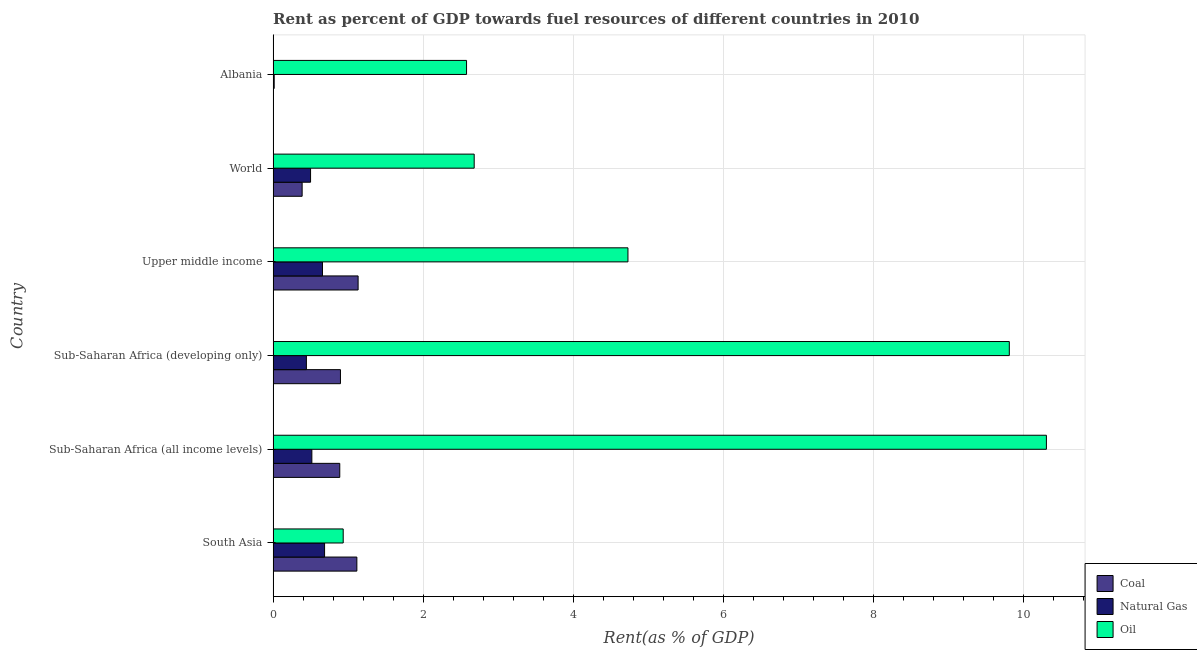How many groups of bars are there?
Your answer should be very brief. 6. Are the number of bars per tick equal to the number of legend labels?
Offer a very short reply. Yes. How many bars are there on the 4th tick from the top?
Keep it short and to the point. 3. What is the label of the 5th group of bars from the top?
Give a very brief answer. Sub-Saharan Africa (all income levels). In how many cases, is the number of bars for a given country not equal to the number of legend labels?
Give a very brief answer. 0. What is the rent towards natural gas in Albania?
Make the answer very short. 0.01. Across all countries, what is the maximum rent towards oil?
Offer a terse response. 10.31. Across all countries, what is the minimum rent towards oil?
Make the answer very short. 0.93. In which country was the rent towards natural gas maximum?
Offer a very short reply. South Asia. In which country was the rent towards coal minimum?
Provide a succinct answer. Albania. What is the total rent towards oil in the graph?
Your answer should be very brief. 31.05. What is the difference between the rent towards coal in Sub-Saharan Africa (all income levels) and that in Upper middle income?
Your response must be concise. -0.24. What is the difference between the rent towards coal in World and the rent towards natural gas in Albania?
Keep it short and to the point. 0.37. What is the average rent towards coal per country?
Your answer should be very brief. 0.74. What is the difference between the rent towards oil and rent towards natural gas in Sub-Saharan Africa (developing only)?
Give a very brief answer. 9.37. In how many countries, is the rent towards coal greater than 3.2 %?
Ensure brevity in your answer.  0. What is the ratio of the rent towards oil in Sub-Saharan Africa (developing only) to that in Upper middle income?
Provide a short and direct response. 2.08. Is the rent towards natural gas in South Asia less than that in Upper middle income?
Give a very brief answer. No. What is the difference between the highest and the second highest rent towards natural gas?
Provide a succinct answer. 0.03. What is the difference between the highest and the lowest rent towards oil?
Give a very brief answer. 9.38. Is the sum of the rent towards oil in Sub-Saharan Africa (developing only) and Upper middle income greater than the maximum rent towards natural gas across all countries?
Keep it short and to the point. Yes. What does the 2nd bar from the top in Upper middle income represents?
Provide a short and direct response. Natural Gas. What does the 1st bar from the bottom in Albania represents?
Provide a succinct answer. Coal. Is it the case that in every country, the sum of the rent towards coal and rent towards natural gas is greater than the rent towards oil?
Your response must be concise. No. How many countries are there in the graph?
Make the answer very short. 6. Are the values on the major ticks of X-axis written in scientific E-notation?
Offer a terse response. No. Where does the legend appear in the graph?
Make the answer very short. Bottom right. How many legend labels are there?
Provide a succinct answer. 3. What is the title of the graph?
Your answer should be compact. Rent as percent of GDP towards fuel resources of different countries in 2010. What is the label or title of the X-axis?
Your answer should be very brief. Rent(as % of GDP). What is the Rent(as % of GDP) of Coal in South Asia?
Offer a very short reply. 1.12. What is the Rent(as % of GDP) in Natural Gas in South Asia?
Make the answer very short. 0.69. What is the Rent(as % of GDP) of Oil in South Asia?
Provide a short and direct response. 0.93. What is the Rent(as % of GDP) in Coal in Sub-Saharan Africa (all income levels)?
Make the answer very short. 0.89. What is the Rent(as % of GDP) in Natural Gas in Sub-Saharan Africa (all income levels)?
Your response must be concise. 0.52. What is the Rent(as % of GDP) in Oil in Sub-Saharan Africa (all income levels)?
Your answer should be compact. 10.31. What is the Rent(as % of GDP) of Coal in Sub-Saharan Africa (developing only)?
Your answer should be compact. 0.9. What is the Rent(as % of GDP) in Natural Gas in Sub-Saharan Africa (developing only)?
Your response must be concise. 0.44. What is the Rent(as % of GDP) in Oil in Sub-Saharan Africa (developing only)?
Keep it short and to the point. 9.82. What is the Rent(as % of GDP) of Coal in Upper middle income?
Keep it short and to the point. 1.13. What is the Rent(as % of GDP) of Natural Gas in Upper middle income?
Keep it short and to the point. 0.66. What is the Rent(as % of GDP) of Oil in Upper middle income?
Make the answer very short. 4.73. What is the Rent(as % of GDP) in Coal in World?
Your response must be concise. 0.39. What is the Rent(as % of GDP) of Natural Gas in World?
Keep it short and to the point. 0.5. What is the Rent(as % of GDP) of Oil in World?
Provide a succinct answer. 2.68. What is the Rent(as % of GDP) in Coal in Albania?
Make the answer very short. 0. What is the Rent(as % of GDP) of Natural Gas in Albania?
Your response must be concise. 0.01. What is the Rent(as % of GDP) in Oil in Albania?
Provide a succinct answer. 2.58. Across all countries, what is the maximum Rent(as % of GDP) in Coal?
Provide a short and direct response. 1.13. Across all countries, what is the maximum Rent(as % of GDP) in Natural Gas?
Give a very brief answer. 0.69. Across all countries, what is the maximum Rent(as % of GDP) of Oil?
Your answer should be compact. 10.31. Across all countries, what is the minimum Rent(as % of GDP) in Coal?
Offer a very short reply. 0. Across all countries, what is the minimum Rent(as % of GDP) in Natural Gas?
Ensure brevity in your answer.  0.01. Across all countries, what is the minimum Rent(as % of GDP) in Oil?
Keep it short and to the point. 0.93. What is the total Rent(as % of GDP) in Coal in the graph?
Keep it short and to the point. 4.42. What is the total Rent(as % of GDP) of Natural Gas in the graph?
Offer a very short reply. 2.82. What is the total Rent(as % of GDP) of Oil in the graph?
Keep it short and to the point. 31.05. What is the difference between the Rent(as % of GDP) of Coal in South Asia and that in Sub-Saharan Africa (all income levels)?
Ensure brevity in your answer.  0.23. What is the difference between the Rent(as % of GDP) in Natural Gas in South Asia and that in Sub-Saharan Africa (all income levels)?
Your answer should be very brief. 0.17. What is the difference between the Rent(as % of GDP) of Oil in South Asia and that in Sub-Saharan Africa (all income levels)?
Your response must be concise. -9.38. What is the difference between the Rent(as % of GDP) in Coal in South Asia and that in Sub-Saharan Africa (developing only)?
Your answer should be very brief. 0.22. What is the difference between the Rent(as % of GDP) in Natural Gas in South Asia and that in Sub-Saharan Africa (developing only)?
Make the answer very short. 0.24. What is the difference between the Rent(as % of GDP) of Oil in South Asia and that in Sub-Saharan Africa (developing only)?
Provide a succinct answer. -8.88. What is the difference between the Rent(as % of GDP) in Coal in South Asia and that in Upper middle income?
Provide a short and direct response. -0.02. What is the difference between the Rent(as % of GDP) in Natural Gas in South Asia and that in Upper middle income?
Your response must be concise. 0.03. What is the difference between the Rent(as % of GDP) in Oil in South Asia and that in Upper middle income?
Provide a short and direct response. -3.8. What is the difference between the Rent(as % of GDP) of Coal in South Asia and that in World?
Your answer should be very brief. 0.73. What is the difference between the Rent(as % of GDP) in Natural Gas in South Asia and that in World?
Offer a terse response. 0.19. What is the difference between the Rent(as % of GDP) of Oil in South Asia and that in World?
Your answer should be very brief. -1.75. What is the difference between the Rent(as % of GDP) in Coal in South Asia and that in Albania?
Provide a succinct answer. 1.12. What is the difference between the Rent(as % of GDP) in Natural Gas in South Asia and that in Albania?
Offer a terse response. 0.67. What is the difference between the Rent(as % of GDP) of Oil in South Asia and that in Albania?
Provide a short and direct response. -1.64. What is the difference between the Rent(as % of GDP) of Coal in Sub-Saharan Africa (all income levels) and that in Sub-Saharan Africa (developing only)?
Keep it short and to the point. -0.01. What is the difference between the Rent(as % of GDP) of Natural Gas in Sub-Saharan Africa (all income levels) and that in Sub-Saharan Africa (developing only)?
Your response must be concise. 0.07. What is the difference between the Rent(as % of GDP) in Oil in Sub-Saharan Africa (all income levels) and that in Sub-Saharan Africa (developing only)?
Your response must be concise. 0.49. What is the difference between the Rent(as % of GDP) in Coal in Sub-Saharan Africa (all income levels) and that in Upper middle income?
Provide a succinct answer. -0.24. What is the difference between the Rent(as % of GDP) in Natural Gas in Sub-Saharan Africa (all income levels) and that in Upper middle income?
Ensure brevity in your answer.  -0.14. What is the difference between the Rent(as % of GDP) in Oil in Sub-Saharan Africa (all income levels) and that in Upper middle income?
Offer a terse response. 5.58. What is the difference between the Rent(as % of GDP) of Coal in Sub-Saharan Africa (all income levels) and that in World?
Your response must be concise. 0.5. What is the difference between the Rent(as % of GDP) in Natural Gas in Sub-Saharan Africa (all income levels) and that in World?
Make the answer very short. 0.02. What is the difference between the Rent(as % of GDP) of Oil in Sub-Saharan Africa (all income levels) and that in World?
Give a very brief answer. 7.63. What is the difference between the Rent(as % of GDP) in Coal in Sub-Saharan Africa (all income levels) and that in Albania?
Make the answer very short. 0.89. What is the difference between the Rent(as % of GDP) in Natural Gas in Sub-Saharan Africa (all income levels) and that in Albania?
Keep it short and to the point. 0.5. What is the difference between the Rent(as % of GDP) of Oil in Sub-Saharan Africa (all income levels) and that in Albania?
Your answer should be very brief. 7.73. What is the difference between the Rent(as % of GDP) of Coal in Sub-Saharan Africa (developing only) and that in Upper middle income?
Offer a very short reply. -0.24. What is the difference between the Rent(as % of GDP) in Natural Gas in Sub-Saharan Africa (developing only) and that in Upper middle income?
Ensure brevity in your answer.  -0.21. What is the difference between the Rent(as % of GDP) of Oil in Sub-Saharan Africa (developing only) and that in Upper middle income?
Keep it short and to the point. 5.08. What is the difference between the Rent(as % of GDP) of Coal in Sub-Saharan Africa (developing only) and that in World?
Your response must be concise. 0.51. What is the difference between the Rent(as % of GDP) of Natural Gas in Sub-Saharan Africa (developing only) and that in World?
Provide a succinct answer. -0.06. What is the difference between the Rent(as % of GDP) of Oil in Sub-Saharan Africa (developing only) and that in World?
Ensure brevity in your answer.  7.13. What is the difference between the Rent(as % of GDP) in Coal in Sub-Saharan Africa (developing only) and that in Albania?
Your answer should be compact. 0.9. What is the difference between the Rent(as % of GDP) in Natural Gas in Sub-Saharan Africa (developing only) and that in Albania?
Keep it short and to the point. 0.43. What is the difference between the Rent(as % of GDP) of Oil in Sub-Saharan Africa (developing only) and that in Albania?
Offer a terse response. 7.24. What is the difference between the Rent(as % of GDP) in Coal in Upper middle income and that in World?
Offer a terse response. 0.75. What is the difference between the Rent(as % of GDP) of Natural Gas in Upper middle income and that in World?
Keep it short and to the point. 0.16. What is the difference between the Rent(as % of GDP) of Oil in Upper middle income and that in World?
Offer a terse response. 2.05. What is the difference between the Rent(as % of GDP) of Coal in Upper middle income and that in Albania?
Give a very brief answer. 1.13. What is the difference between the Rent(as % of GDP) in Natural Gas in Upper middle income and that in Albania?
Make the answer very short. 0.64. What is the difference between the Rent(as % of GDP) in Oil in Upper middle income and that in Albania?
Your answer should be very brief. 2.15. What is the difference between the Rent(as % of GDP) in Coal in World and that in Albania?
Offer a terse response. 0.39. What is the difference between the Rent(as % of GDP) of Natural Gas in World and that in Albania?
Ensure brevity in your answer.  0.49. What is the difference between the Rent(as % of GDP) in Oil in World and that in Albania?
Provide a succinct answer. 0.1. What is the difference between the Rent(as % of GDP) of Coal in South Asia and the Rent(as % of GDP) of Oil in Sub-Saharan Africa (all income levels)?
Provide a short and direct response. -9.19. What is the difference between the Rent(as % of GDP) in Natural Gas in South Asia and the Rent(as % of GDP) in Oil in Sub-Saharan Africa (all income levels)?
Your answer should be compact. -9.62. What is the difference between the Rent(as % of GDP) in Coal in South Asia and the Rent(as % of GDP) in Natural Gas in Sub-Saharan Africa (developing only)?
Your answer should be very brief. 0.67. What is the difference between the Rent(as % of GDP) in Coal in South Asia and the Rent(as % of GDP) in Oil in Sub-Saharan Africa (developing only)?
Provide a short and direct response. -8.7. What is the difference between the Rent(as % of GDP) of Natural Gas in South Asia and the Rent(as % of GDP) of Oil in Sub-Saharan Africa (developing only)?
Your answer should be very brief. -9.13. What is the difference between the Rent(as % of GDP) in Coal in South Asia and the Rent(as % of GDP) in Natural Gas in Upper middle income?
Offer a terse response. 0.46. What is the difference between the Rent(as % of GDP) in Coal in South Asia and the Rent(as % of GDP) in Oil in Upper middle income?
Ensure brevity in your answer.  -3.61. What is the difference between the Rent(as % of GDP) of Natural Gas in South Asia and the Rent(as % of GDP) of Oil in Upper middle income?
Make the answer very short. -4.04. What is the difference between the Rent(as % of GDP) of Coal in South Asia and the Rent(as % of GDP) of Natural Gas in World?
Offer a very short reply. 0.62. What is the difference between the Rent(as % of GDP) in Coal in South Asia and the Rent(as % of GDP) in Oil in World?
Offer a very short reply. -1.56. What is the difference between the Rent(as % of GDP) in Natural Gas in South Asia and the Rent(as % of GDP) in Oil in World?
Ensure brevity in your answer.  -1.99. What is the difference between the Rent(as % of GDP) of Coal in South Asia and the Rent(as % of GDP) of Natural Gas in Albania?
Your answer should be compact. 1.1. What is the difference between the Rent(as % of GDP) in Coal in South Asia and the Rent(as % of GDP) in Oil in Albania?
Your answer should be very brief. -1.46. What is the difference between the Rent(as % of GDP) of Natural Gas in South Asia and the Rent(as % of GDP) of Oil in Albania?
Ensure brevity in your answer.  -1.89. What is the difference between the Rent(as % of GDP) in Coal in Sub-Saharan Africa (all income levels) and the Rent(as % of GDP) in Natural Gas in Sub-Saharan Africa (developing only)?
Your answer should be compact. 0.45. What is the difference between the Rent(as % of GDP) of Coal in Sub-Saharan Africa (all income levels) and the Rent(as % of GDP) of Oil in Sub-Saharan Africa (developing only)?
Ensure brevity in your answer.  -8.93. What is the difference between the Rent(as % of GDP) of Natural Gas in Sub-Saharan Africa (all income levels) and the Rent(as % of GDP) of Oil in Sub-Saharan Africa (developing only)?
Provide a succinct answer. -9.3. What is the difference between the Rent(as % of GDP) in Coal in Sub-Saharan Africa (all income levels) and the Rent(as % of GDP) in Natural Gas in Upper middle income?
Provide a succinct answer. 0.23. What is the difference between the Rent(as % of GDP) of Coal in Sub-Saharan Africa (all income levels) and the Rent(as % of GDP) of Oil in Upper middle income?
Offer a very short reply. -3.84. What is the difference between the Rent(as % of GDP) in Natural Gas in Sub-Saharan Africa (all income levels) and the Rent(as % of GDP) in Oil in Upper middle income?
Ensure brevity in your answer.  -4.21. What is the difference between the Rent(as % of GDP) in Coal in Sub-Saharan Africa (all income levels) and the Rent(as % of GDP) in Natural Gas in World?
Your answer should be very brief. 0.39. What is the difference between the Rent(as % of GDP) in Coal in Sub-Saharan Africa (all income levels) and the Rent(as % of GDP) in Oil in World?
Keep it short and to the point. -1.79. What is the difference between the Rent(as % of GDP) in Natural Gas in Sub-Saharan Africa (all income levels) and the Rent(as % of GDP) in Oil in World?
Give a very brief answer. -2.16. What is the difference between the Rent(as % of GDP) of Coal in Sub-Saharan Africa (all income levels) and the Rent(as % of GDP) of Natural Gas in Albania?
Ensure brevity in your answer.  0.87. What is the difference between the Rent(as % of GDP) of Coal in Sub-Saharan Africa (all income levels) and the Rent(as % of GDP) of Oil in Albania?
Keep it short and to the point. -1.69. What is the difference between the Rent(as % of GDP) in Natural Gas in Sub-Saharan Africa (all income levels) and the Rent(as % of GDP) in Oil in Albania?
Make the answer very short. -2.06. What is the difference between the Rent(as % of GDP) in Coal in Sub-Saharan Africa (developing only) and the Rent(as % of GDP) in Natural Gas in Upper middle income?
Your answer should be very brief. 0.24. What is the difference between the Rent(as % of GDP) in Coal in Sub-Saharan Africa (developing only) and the Rent(as % of GDP) in Oil in Upper middle income?
Your response must be concise. -3.83. What is the difference between the Rent(as % of GDP) in Natural Gas in Sub-Saharan Africa (developing only) and the Rent(as % of GDP) in Oil in Upper middle income?
Make the answer very short. -4.29. What is the difference between the Rent(as % of GDP) of Coal in Sub-Saharan Africa (developing only) and the Rent(as % of GDP) of Natural Gas in World?
Offer a terse response. 0.4. What is the difference between the Rent(as % of GDP) in Coal in Sub-Saharan Africa (developing only) and the Rent(as % of GDP) in Oil in World?
Your answer should be compact. -1.78. What is the difference between the Rent(as % of GDP) of Natural Gas in Sub-Saharan Africa (developing only) and the Rent(as % of GDP) of Oil in World?
Make the answer very short. -2.24. What is the difference between the Rent(as % of GDP) of Coal in Sub-Saharan Africa (developing only) and the Rent(as % of GDP) of Natural Gas in Albania?
Your answer should be very brief. 0.88. What is the difference between the Rent(as % of GDP) of Coal in Sub-Saharan Africa (developing only) and the Rent(as % of GDP) of Oil in Albania?
Provide a succinct answer. -1.68. What is the difference between the Rent(as % of GDP) of Natural Gas in Sub-Saharan Africa (developing only) and the Rent(as % of GDP) of Oil in Albania?
Your answer should be compact. -2.14. What is the difference between the Rent(as % of GDP) of Coal in Upper middle income and the Rent(as % of GDP) of Natural Gas in World?
Your answer should be compact. 0.63. What is the difference between the Rent(as % of GDP) in Coal in Upper middle income and the Rent(as % of GDP) in Oil in World?
Your answer should be compact. -1.55. What is the difference between the Rent(as % of GDP) in Natural Gas in Upper middle income and the Rent(as % of GDP) in Oil in World?
Your answer should be compact. -2.02. What is the difference between the Rent(as % of GDP) of Coal in Upper middle income and the Rent(as % of GDP) of Natural Gas in Albania?
Offer a very short reply. 1.12. What is the difference between the Rent(as % of GDP) in Coal in Upper middle income and the Rent(as % of GDP) in Oil in Albania?
Provide a succinct answer. -1.45. What is the difference between the Rent(as % of GDP) in Natural Gas in Upper middle income and the Rent(as % of GDP) in Oil in Albania?
Your response must be concise. -1.92. What is the difference between the Rent(as % of GDP) in Coal in World and the Rent(as % of GDP) in Natural Gas in Albania?
Your answer should be compact. 0.37. What is the difference between the Rent(as % of GDP) in Coal in World and the Rent(as % of GDP) in Oil in Albania?
Your answer should be compact. -2.19. What is the difference between the Rent(as % of GDP) of Natural Gas in World and the Rent(as % of GDP) of Oil in Albania?
Keep it short and to the point. -2.08. What is the average Rent(as % of GDP) of Coal per country?
Provide a short and direct response. 0.74. What is the average Rent(as % of GDP) of Natural Gas per country?
Ensure brevity in your answer.  0.47. What is the average Rent(as % of GDP) in Oil per country?
Offer a very short reply. 5.18. What is the difference between the Rent(as % of GDP) of Coal and Rent(as % of GDP) of Natural Gas in South Asia?
Provide a succinct answer. 0.43. What is the difference between the Rent(as % of GDP) in Coal and Rent(as % of GDP) in Oil in South Asia?
Make the answer very short. 0.18. What is the difference between the Rent(as % of GDP) of Natural Gas and Rent(as % of GDP) of Oil in South Asia?
Offer a very short reply. -0.25. What is the difference between the Rent(as % of GDP) of Coal and Rent(as % of GDP) of Natural Gas in Sub-Saharan Africa (all income levels)?
Ensure brevity in your answer.  0.37. What is the difference between the Rent(as % of GDP) in Coal and Rent(as % of GDP) in Oil in Sub-Saharan Africa (all income levels)?
Provide a succinct answer. -9.42. What is the difference between the Rent(as % of GDP) in Natural Gas and Rent(as % of GDP) in Oil in Sub-Saharan Africa (all income levels)?
Provide a succinct answer. -9.79. What is the difference between the Rent(as % of GDP) of Coal and Rent(as % of GDP) of Natural Gas in Sub-Saharan Africa (developing only)?
Provide a short and direct response. 0.45. What is the difference between the Rent(as % of GDP) of Coal and Rent(as % of GDP) of Oil in Sub-Saharan Africa (developing only)?
Make the answer very short. -8.92. What is the difference between the Rent(as % of GDP) in Natural Gas and Rent(as % of GDP) in Oil in Sub-Saharan Africa (developing only)?
Offer a terse response. -9.37. What is the difference between the Rent(as % of GDP) in Coal and Rent(as % of GDP) in Natural Gas in Upper middle income?
Provide a succinct answer. 0.48. What is the difference between the Rent(as % of GDP) of Coal and Rent(as % of GDP) of Oil in Upper middle income?
Your answer should be very brief. -3.6. What is the difference between the Rent(as % of GDP) in Natural Gas and Rent(as % of GDP) in Oil in Upper middle income?
Keep it short and to the point. -4.07. What is the difference between the Rent(as % of GDP) of Coal and Rent(as % of GDP) of Natural Gas in World?
Ensure brevity in your answer.  -0.11. What is the difference between the Rent(as % of GDP) of Coal and Rent(as % of GDP) of Oil in World?
Offer a terse response. -2.29. What is the difference between the Rent(as % of GDP) of Natural Gas and Rent(as % of GDP) of Oil in World?
Offer a terse response. -2.18. What is the difference between the Rent(as % of GDP) in Coal and Rent(as % of GDP) in Natural Gas in Albania?
Your answer should be compact. -0.01. What is the difference between the Rent(as % of GDP) of Coal and Rent(as % of GDP) of Oil in Albania?
Make the answer very short. -2.58. What is the difference between the Rent(as % of GDP) in Natural Gas and Rent(as % of GDP) in Oil in Albania?
Your answer should be compact. -2.56. What is the ratio of the Rent(as % of GDP) of Coal in South Asia to that in Sub-Saharan Africa (all income levels)?
Make the answer very short. 1.26. What is the ratio of the Rent(as % of GDP) in Natural Gas in South Asia to that in Sub-Saharan Africa (all income levels)?
Offer a very short reply. 1.33. What is the ratio of the Rent(as % of GDP) of Oil in South Asia to that in Sub-Saharan Africa (all income levels)?
Offer a very short reply. 0.09. What is the ratio of the Rent(as % of GDP) of Coal in South Asia to that in Sub-Saharan Africa (developing only)?
Provide a succinct answer. 1.24. What is the ratio of the Rent(as % of GDP) in Natural Gas in South Asia to that in Sub-Saharan Africa (developing only)?
Provide a succinct answer. 1.55. What is the ratio of the Rent(as % of GDP) in Oil in South Asia to that in Sub-Saharan Africa (developing only)?
Ensure brevity in your answer.  0.1. What is the ratio of the Rent(as % of GDP) in Coal in South Asia to that in Upper middle income?
Provide a short and direct response. 0.99. What is the ratio of the Rent(as % of GDP) of Natural Gas in South Asia to that in Upper middle income?
Offer a very short reply. 1.04. What is the ratio of the Rent(as % of GDP) of Oil in South Asia to that in Upper middle income?
Keep it short and to the point. 0.2. What is the ratio of the Rent(as % of GDP) in Coal in South Asia to that in World?
Offer a terse response. 2.89. What is the ratio of the Rent(as % of GDP) of Natural Gas in South Asia to that in World?
Your response must be concise. 1.37. What is the ratio of the Rent(as % of GDP) in Oil in South Asia to that in World?
Provide a short and direct response. 0.35. What is the ratio of the Rent(as % of GDP) of Coal in South Asia to that in Albania?
Make the answer very short. 8885.62. What is the ratio of the Rent(as % of GDP) in Natural Gas in South Asia to that in Albania?
Offer a very short reply. 48.52. What is the ratio of the Rent(as % of GDP) of Oil in South Asia to that in Albania?
Keep it short and to the point. 0.36. What is the ratio of the Rent(as % of GDP) of Coal in Sub-Saharan Africa (all income levels) to that in Sub-Saharan Africa (developing only)?
Give a very brief answer. 0.99. What is the ratio of the Rent(as % of GDP) in Natural Gas in Sub-Saharan Africa (all income levels) to that in Sub-Saharan Africa (developing only)?
Keep it short and to the point. 1.16. What is the ratio of the Rent(as % of GDP) of Oil in Sub-Saharan Africa (all income levels) to that in Sub-Saharan Africa (developing only)?
Your response must be concise. 1.05. What is the ratio of the Rent(as % of GDP) in Coal in Sub-Saharan Africa (all income levels) to that in Upper middle income?
Keep it short and to the point. 0.78. What is the ratio of the Rent(as % of GDP) of Natural Gas in Sub-Saharan Africa (all income levels) to that in Upper middle income?
Your answer should be very brief. 0.78. What is the ratio of the Rent(as % of GDP) in Oil in Sub-Saharan Africa (all income levels) to that in Upper middle income?
Keep it short and to the point. 2.18. What is the ratio of the Rent(as % of GDP) of Coal in Sub-Saharan Africa (all income levels) to that in World?
Ensure brevity in your answer.  2.3. What is the ratio of the Rent(as % of GDP) of Natural Gas in Sub-Saharan Africa (all income levels) to that in World?
Your answer should be compact. 1.03. What is the ratio of the Rent(as % of GDP) in Oil in Sub-Saharan Africa (all income levels) to that in World?
Your answer should be very brief. 3.85. What is the ratio of the Rent(as % of GDP) of Coal in Sub-Saharan Africa (all income levels) to that in Albania?
Keep it short and to the point. 7072.07. What is the ratio of the Rent(as % of GDP) of Natural Gas in Sub-Saharan Africa (all income levels) to that in Albania?
Ensure brevity in your answer.  36.53. What is the ratio of the Rent(as % of GDP) of Oil in Sub-Saharan Africa (all income levels) to that in Albania?
Provide a short and direct response. 4. What is the ratio of the Rent(as % of GDP) in Coal in Sub-Saharan Africa (developing only) to that in Upper middle income?
Give a very brief answer. 0.79. What is the ratio of the Rent(as % of GDP) of Natural Gas in Sub-Saharan Africa (developing only) to that in Upper middle income?
Your answer should be compact. 0.67. What is the ratio of the Rent(as % of GDP) of Oil in Sub-Saharan Africa (developing only) to that in Upper middle income?
Your answer should be compact. 2.07. What is the ratio of the Rent(as % of GDP) in Coal in Sub-Saharan Africa (developing only) to that in World?
Provide a succinct answer. 2.32. What is the ratio of the Rent(as % of GDP) in Natural Gas in Sub-Saharan Africa (developing only) to that in World?
Offer a very short reply. 0.89. What is the ratio of the Rent(as % of GDP) of Oil in Sub-Saharan Africa (developing only) to that in World?
Make the answer very short. 3.66. What is the ratio of the Rent(as % of GDP) of Coal in Sub-Saharan Africa (developing only) to that in Albania?
Offer a terse response. 7144.35. What is the ratio of the Rent(as % of GDP) in Natural Gas in Sub-Saharan Africa (developing only) to that in Albania?
Offer a very short reply. 31.37. What is the ratio of the Rent(as % of GDP) of Oil in Sub-Saharan Africa (developing only) to that in Albania?
Offer a terse response. 3.81. What is the ratio of the Rent(as % of GDP) of Coal in Upper middle income to that in World?
Ensure brevity in your answer.  2.93. What is the ratio of the Rent(as % of GDP) of Natural Gas in Upper middle income to that in World?
Provide a short and direct response. 1.32. What is the ratio of the Rent(as % of GDP) in Oil in Upper middle income to that in World?
Your answer should be compact. 1.76. What is the ratio of the Rent(as % of GDP) of Coal in Upper middle income to that in Albania?
Provide a succinct answer. 9018.84. What is the ratio of the Rent(as % of GDP) of Natural Gas in Upper middle income to that in Albania?
Keep it short and to the point. 46.55. What is the ratio of the Rent(as % of GDP) of Oil in Upper middle income to that in Albania?
Your answer should be very brief. 1.83. What is the ratio of the Rent(as % of GDP) of Coal in World to that in Albania?
Make the answer very short. 3079.02. What is the ratio of the Rent(as % of GDP) in Natural Gas in World to that in Albania?
Your response must be concise. 35.31. What is the ratio of the Rent(as % of GDP) in Oil in World to that in Albania?
Provide a succinct answer. 1.04. What is the difference between the highest and the second highest Rent(as % of GDP) of Coal?
Keep it short and to the point. 0.02. What is the difference between the highest and the second highest Rent(as % of GDP) of Natural Gas?
Your answer should be compact. 0.03. What is the difference between the highest and the second highest Rent(as % of GDP) of Oil?
Make the answer very short. 0.49. What is the difference between the highest and the lowest Rent(as % of GDP) in Coal?
Give a very brief answer. 1.13. What is the difference between the highest and the lowest Rent(as % of GDP) of Natural Gas?
Ensure brevity in your answer.  0.67. What is the difference between the highest and the lowest Rent(as % of GDP) in Oil?
Your answer should be very brief. 9.38. 